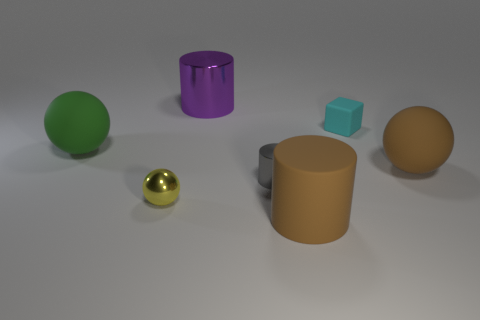There is a metal cylinder behind the green ball that is in front of the rubber block; what size is it?
Provide a succinct answer. Large. How many objects are large cyan cylinders or small objects?
Your answer should be compact. 3. Is there a object that has the same color as the block?
Make the answer very short. No. Are there fewer gray shiny cylinders than large yellow rubber cylinders?
Provide a short and direct response. No. What number of things are either green spheres or large rubber spheres that are left of the large brown matte sphere?
Provide a short and direct response. 1. Are there any large gray objects made of the same material as the big purple object?
Keep it short and to the point. No. What is the material of the green sphere that is the same size as the rubber cylinder?
Offer a very short reply. Rubber. The cylinder behind the matte thing on the right side of the cyan cube is made of what material?
Keep it short and to the point. Metal. Is the shape of the big matte thing that is on the right side of the cyan rubber block the same as  the cyan matte thing?
Your answer should be very brief. No. What color is the tiny object that is the same material as the large green thing?
Ensure brevity in your answer.  Cyan. 